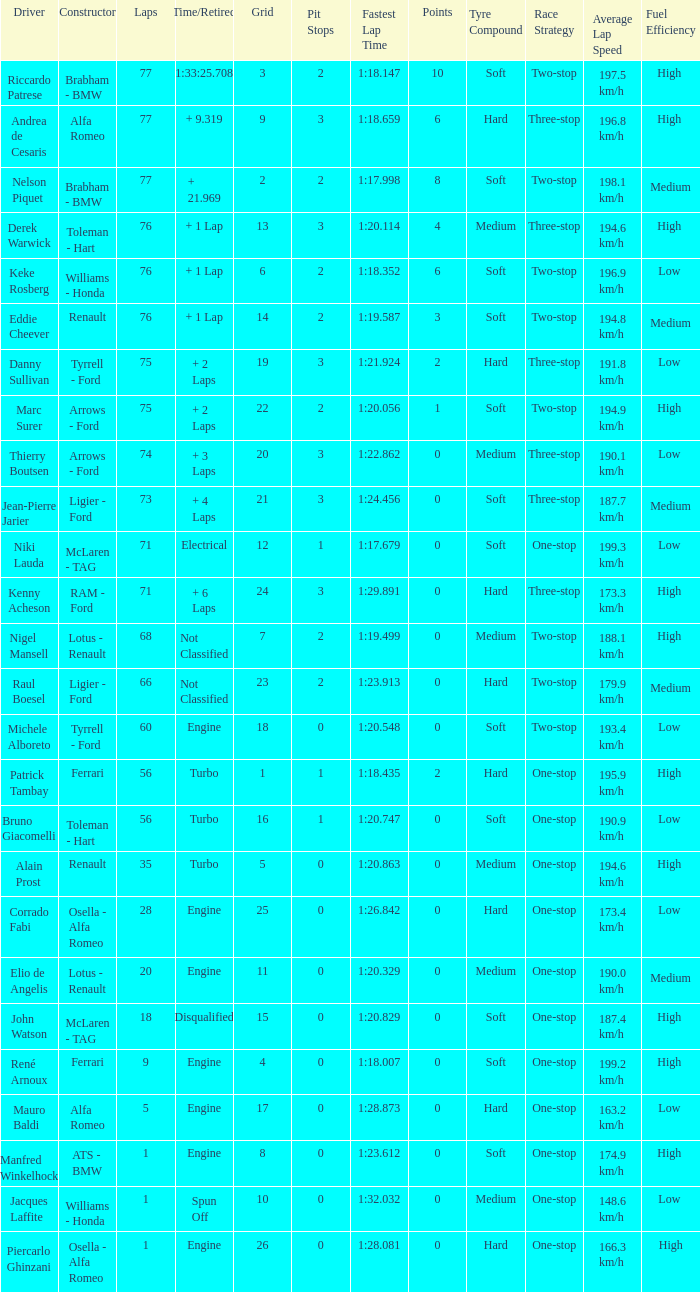Who drove the grid 10 car? Jacques Laffite. 